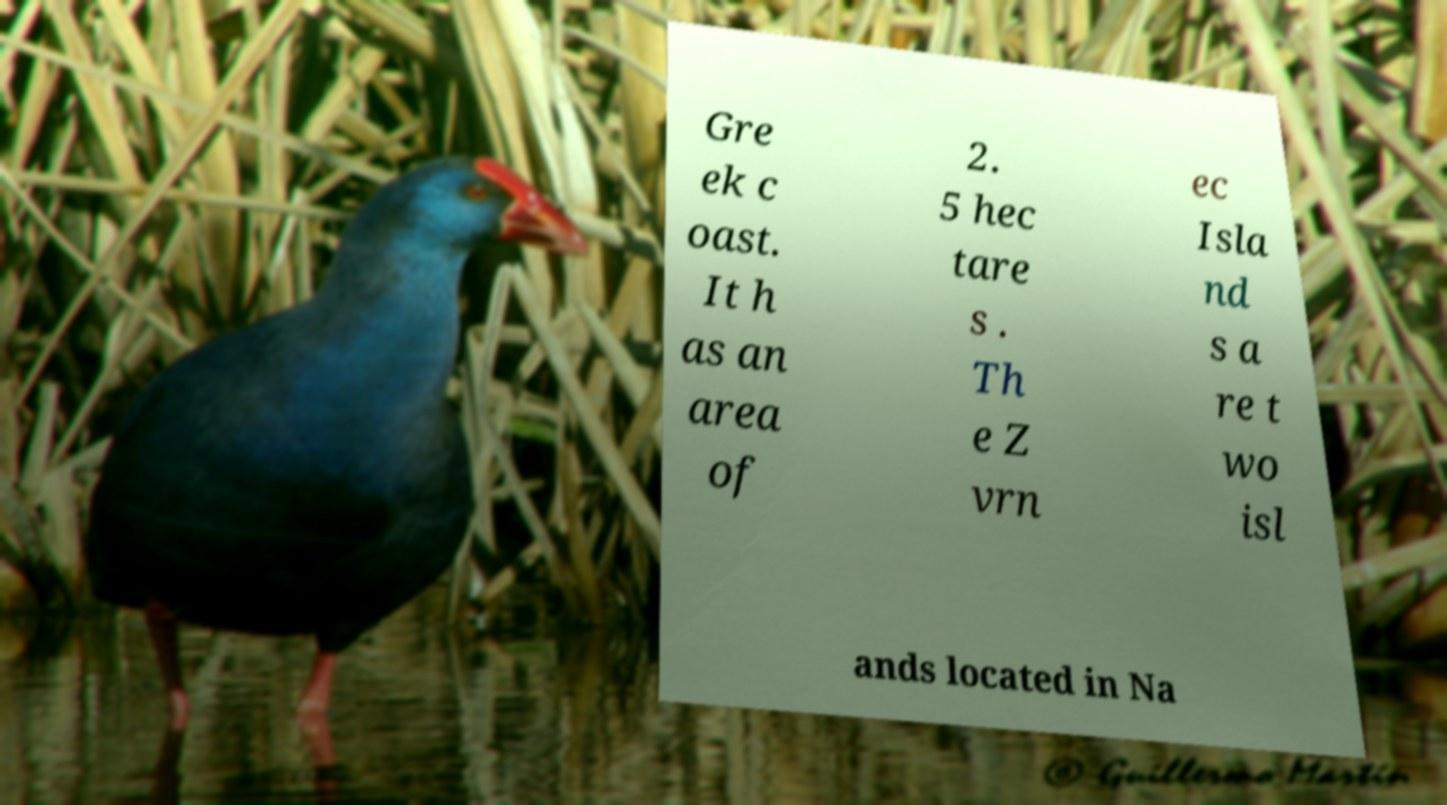There's text embedded in this image that I need extracted. Can you transcribe it verbatim? Gre ek c oast. It h as an area of 2. 5 hec tare s . Th e Z vrn ec Isla nd s a re t wo isl ands located in Na 